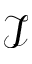<formula> <loc_0><loc_0><loc_500><loc_500>\mathcal { I }</formula> 